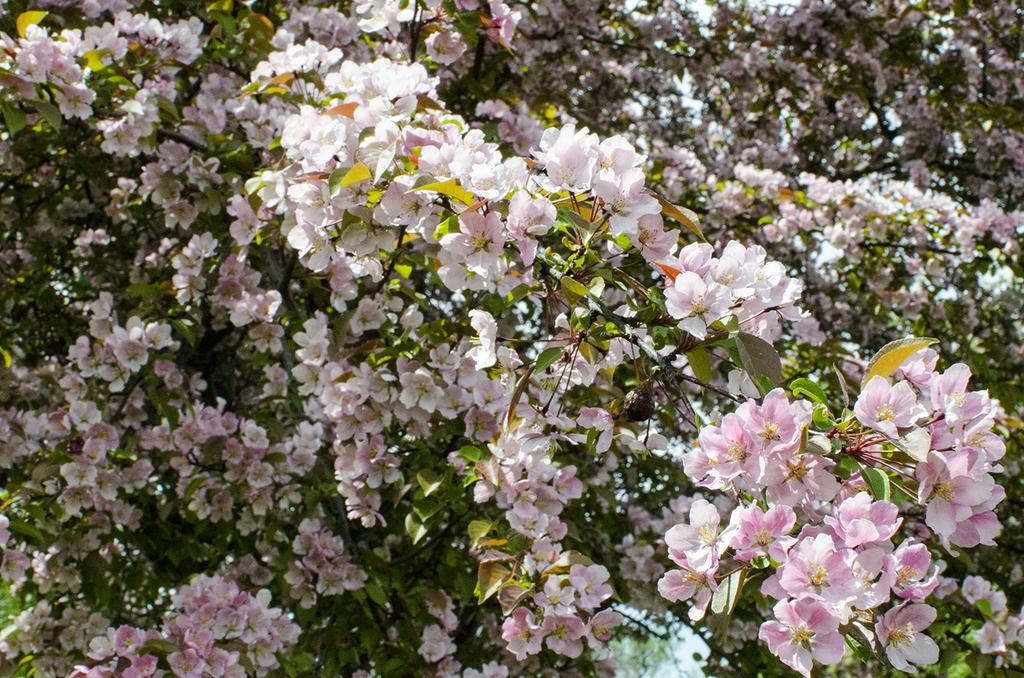What type of vegetation can be seen in the image? There is a group of plants and a bunch of flowers in the image. Can you describe the plants in the image? The image only shows a group of plants and a bunch of flowers, but no specific details about the plants are provided. What type of carpenter tool can be seen in the image? There is no carpenter tool present in the image. How does the river flow in the image? There is no river present in the image. 